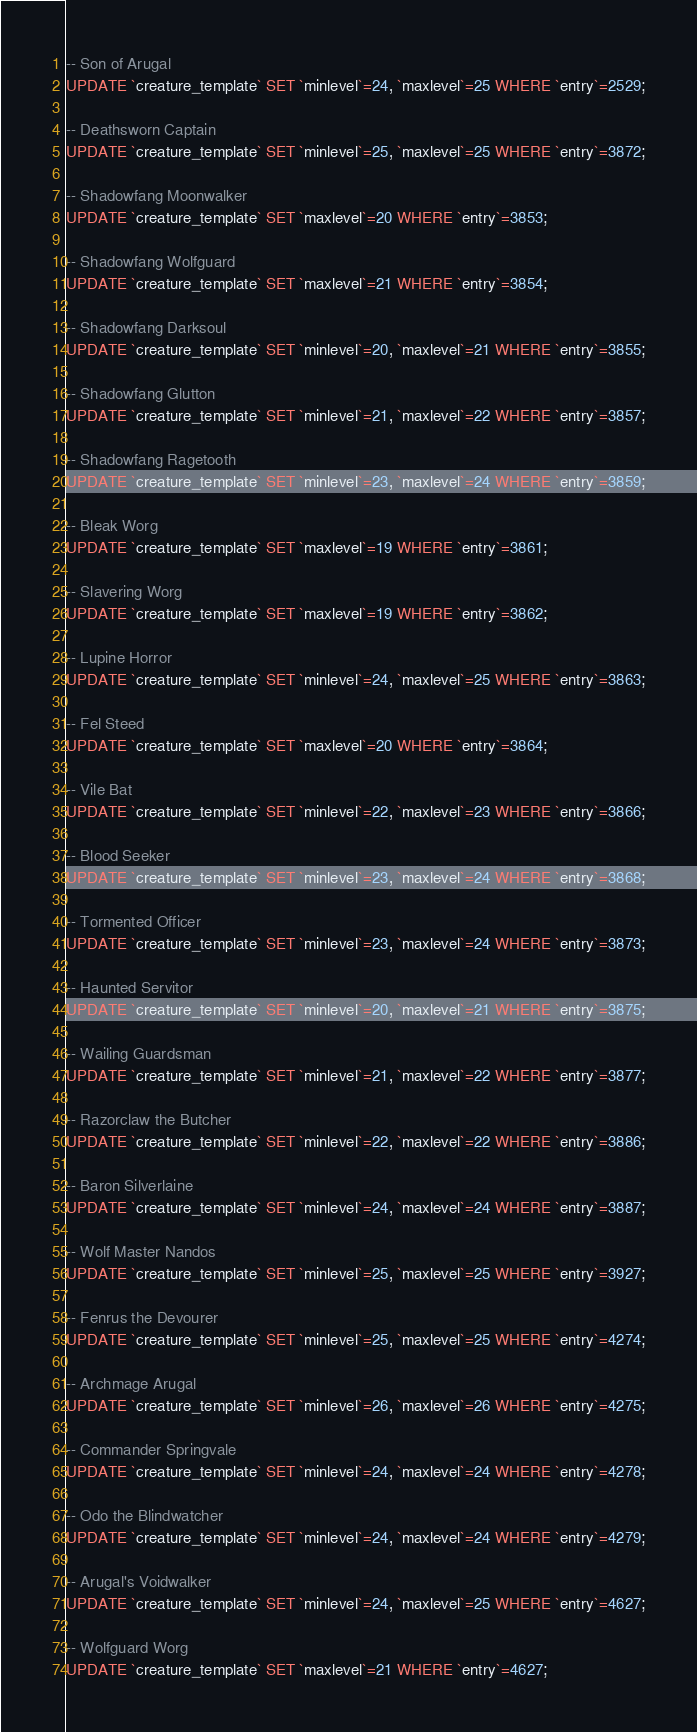<code> <loc_0><loc_0><loc_500><loc_500><_SQL_>-- Son of Arugal
UPDATE `creature_template` SET `minlevel`=24, `maxlevel`=25 WHERE `entry`=2529;

-- Deathsworn Captain
UPDATE `creature_template` SET `minlevel`=25, `maxlevel`=25 WHERE `entry`=3872;

-- Shadowfang Moonwalker
UPDATE `creature_template` SET `maxlevel`=20 WHERE `entry`=3853;

-- Shadowfang Wolfguard
UPDATE `creature_template` SET `maxlevel`=21 WHERE `entry`=3854;

-- Shadowfang Darksoul
UPDATE `creature_template` SET `minlevel`=20, `maxlevel`=21 WHERE `entry`=3855;

-- Shadowfang Glutton
UPDATE `creature_template` SET `minlevel`=21, `maxlevel`=22 WHERE `entry`=3857;

-- Shadowfang Ragetooth
UPDATE `creature_template` SET `minlevel`=23, `maxlevel`=24 WHERE `entry`=3859;

-- Bleak Worg
UPDATE `creature_template` SET `maxlevel`=19 WHERE `entry`=3861;

-- Slavering Worg
UPDATE `creature_template` SET `maxlevel`=19 WHERE `entry`=3862;

-- Lupine Horror
UPDATE `creature_template` SET `minlevel`=24, `maxlevel`=25 WHERE `entry`=3863;

-- Fel Steed
UPDATE `creature_template` SET `maxlevel`=20 WHERE `entry`=3864;

-- Vile Bat
UPDATE `creature_template` SET `minlevel`=22, `maxlevel`=23 WHERE `entry`=3866;

-- Blood Seeker
UPDATE `creature_template` SET `minlevel`=23, `maxlevel`=24 WHERE `entry`=3868;

-- Tormented Officer
UPDATE `creature_template` SET `minlevel`=23, `maxlevel`=24 WHERE `entry`=3873;

-- Haunted Servitor
UPDATE `creature_template` SET `minlevel`=20, `maxlevel`=21 WHERE `entry`=3875;

-- Wailing Guardsman
UPDATE `creature_template` SET `minlevel`=21, `maxlevel`=22 WHERE `entry`=3877;

-- Razorclaw the Butcher
UPDATE `creature_template` SET `minlevel`=22, `maxlevel`=22 WHERE `entry`=3886;

-- Baron Silverlaine
UPDATE `creature_template` SET `minlevel`=24, `maxlevel`=24 WHERE `entry`=3887;

-- Wolf Master Nandos
UPDATE `creature_template` SET `minlevel`=25, `maxlevel`=25 WHERE `entry`=3927;

-- Fenrus the Devourer
UPDATE `creature_template` SET `minlevel`=25, `maxlevel`=25 WHERE `entry`=4274;

-- Archmage Arugal
UPDATE `creature_template` SET `minlevel`=26, `maxlevel`=26 WHERE `entry`=4275;

-- Commander Springvale
UPDATE `creature_template` SET `minlevel`=24, `maxlevel`=24 WHERE `entry`=4278;

-- Odo the Blindwatcher
UPDATE `creature_template` SET `minlevel`=24, `maxlevel`=24 WHERE `entry`=4279;

-- Arugal's Voidwalker
UPDATE `creature_template` SET `minlevel`=24, `maxlevel`=25 WHERE `entry`=4627;

-- Wolfguard Worg
UPDATE `creature_template` SET `maxlevel`=21 WHERE `entry`=4627;
</code> 